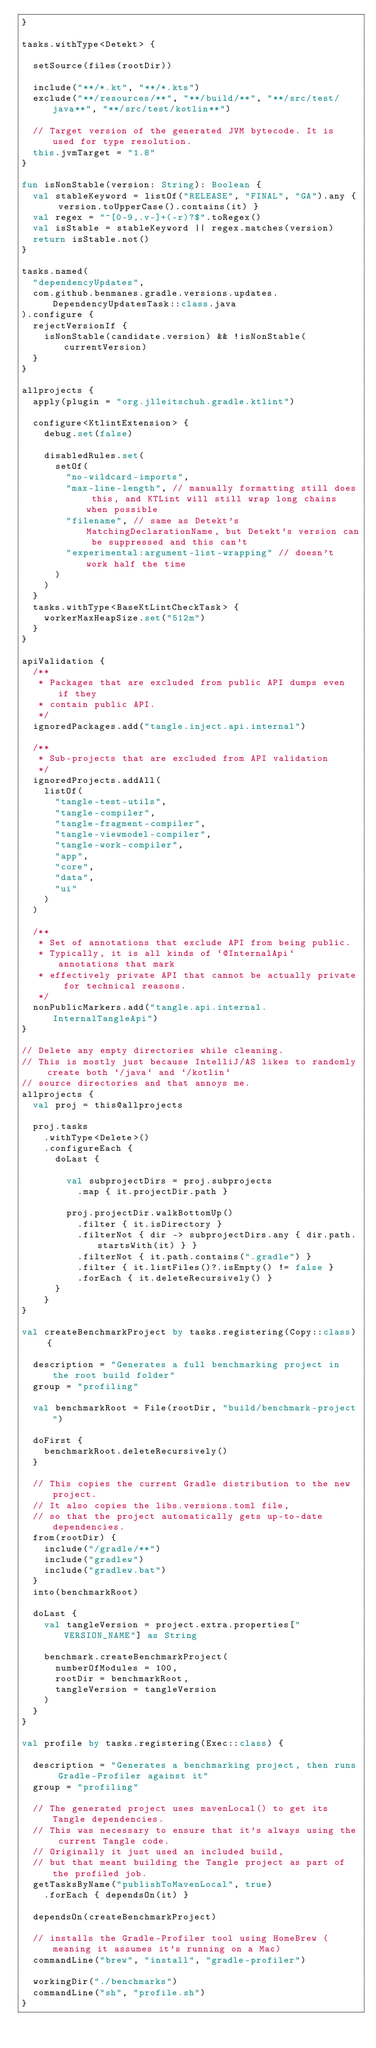<code> <loc_0><loc_0><loc_500><loc_500><_Kotlin_>}

tasks.withType<Detekt> {

  setSource(files(rootDir))

  include("**/*.kt", "**/*.kts")
  exclude("**/resources/**", "**/build/**", "**/src/test/java**", "**/src/test/kotlin**")

  // Target version of the generated JVM bytecode. It is used for type resolution.
  this.jvmTarget = "1.8"
}

fun isNonStable(version: String): Boolean {
  val stableKeyword = listOf("RELEASE", "FINAL", "GA").any { version.toUpperCase().contains(it) }
  val regex = "^[0-9,.v-]+(-r)?$".toRegex()
  val isStable = stableKeyword || regex.matches(version)
  return isStable.not()
}

tasks.named(
  "dependencyUpdates",
  com.github.benmanes.gradle.versions.updates.DependencyUpdatesTask::class.java
).configure {
  rejectVersionIf {
    isNonStable(candidate.version) && !isNonStable(currentVersion)
  }
}

allprojects {
  apply(plugin = "org.jlleitschuh.gradle.ktlint")

  configure<KtlintExtension> {
    debug.set(false)

    disabledRules.set(
      setOf(
        "no-wildcard-imports",
        "max-line-length", // manually formatting still does this, and KTLint will still wrap long chains when possible
        "filename", // same as Detekt's MatchingDeclarationName, but Detekt's version can be suppressed and this can't
        "experimental:argument-list-wrapping" // doesn't work half the time
      )
    )
  }
  tasks.withType<BaseKtLintCheckTask> {
    workerMaxHeapSize.set("512m")
  }
}

apiValidation {
  /**
   * Packages that are excluded from public API dumps even if they
   * contain public API.
   */
  ignoredPackages.add("tangle.inject.api.internal")

  /**
   * Sub-projects that are excluded from API validation
   */
  ignoredProjects.addAll(
    listOf(
      "tangle-test-utils",
      "tangle-compiler",
      "tangle-fragment-compiler",
      "tangle-viewmodel-compiler",
      "tangle-work-compiler",
      "app",
      "core",
      "data",
      "ui"
    )
  )

  /**
   * Set of annotations that exclude API from being public.
   * Typically, it is all kinds of `@InternalApi` annotations that mark
   * effectively private API that cannot be actually private for technical reasons.
   */
  nonPublicMarkers.add("tangle.api.internal.InternalTangleApi")
}

// Delete any empty directories while cleaning.
// This is mostly just because IntelliJ/AS likes to randomly create both `/java` and `/kotlin`
// source directories and that annoys me.
allprojects {
  val proj = this@allprojects

  proj.tasks
    .withType<Delete>()
    .configureEach {
      doLast {

        val subprojectDirs = proj.subprojects
          .map { it.projectDir.path }

        proj.projectDir.walkBottomUp()
          .filter { it.isDirectory }
          .filterNot { dir -> subprojectDirs.any { dir.path.startsWith(it) } }
          .filterNot { it.path.contains(".gradle") }
          .filter { it.listFiles()?.isEmpty() != false }
          .forEach { it.deleteRecursively() }
      }
    }
}

val createBenchmarkProject by tasks.registering(Copy::class) {

  description = "Generates a full benchmarking project in the root build folder"
  group = "profiling"

  val benchmarkRoot = File(rootDir, "build/benchmark-project")

  doFirst {
    benchmarkRoot.deleteRecursively()
  }

  // This copies the current Gradle distribution to the new project.
  // It also copies the libs.versions.toml file,
  // so that the project automatically gets up-to-date dependencies.
  from(rootDir) {
    include("/gradle/**")
    include("gradlew")
    include("gradlew.bat")
  }
  into(benchmarkRoot)

  doLast {
    val tangleVersion = project.extra.properties["VERSION_NAME"] as String

    benchmark.createBenchmarkProject(
      numberOfModules = 100,
      rootDir = benchmarkRoot,
      tangleVersion = tangleVersion
    )
  }
}

val profile by tasks.registering(Exec::class) {

  description = "Generates a benchmarking project, then runs Gradle-Profiler against it"
  group = "profiling"

  // The generated project uses mavenLocal() to get its Tangle dependencies.
  // This was necessary to ensure that it's always using the current Tangle code.
  // Originally it just used an included build,
  // but that meant building the Tangle project as part of the profiled job.
  getTasksByName("publishToMavenLocal", true)
    .forEach { dependsOn(it) }

  dependsOn(createBenchmarkProject)

  // installs the Gradle-Profiler tool using HomeBrew (meaning it assumes it's running on a Mac)
  commandLine("brew", "install", "gradle-profiler")

  workingDir("./benchmarks")
  commandLine("sh", "profile.sh")
}
</code> 